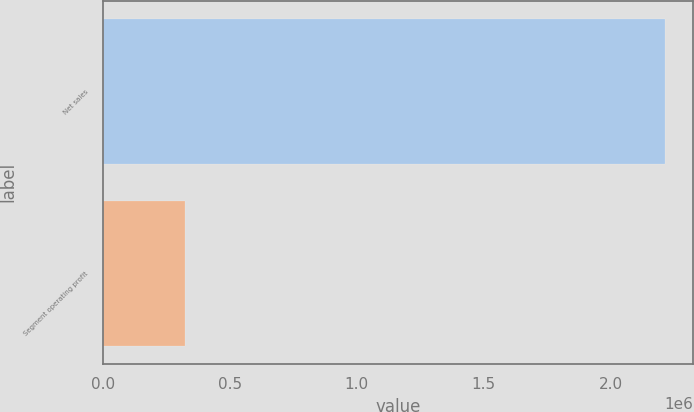Convert chart to OTSL. <chart><loc_0><loc_0><loc_500><loc_500><bar_chart><fcel>Net sales<fcel>Segment operating profit<nl><fcel>2.21403e+06<fcel>322564<nl></chart> 